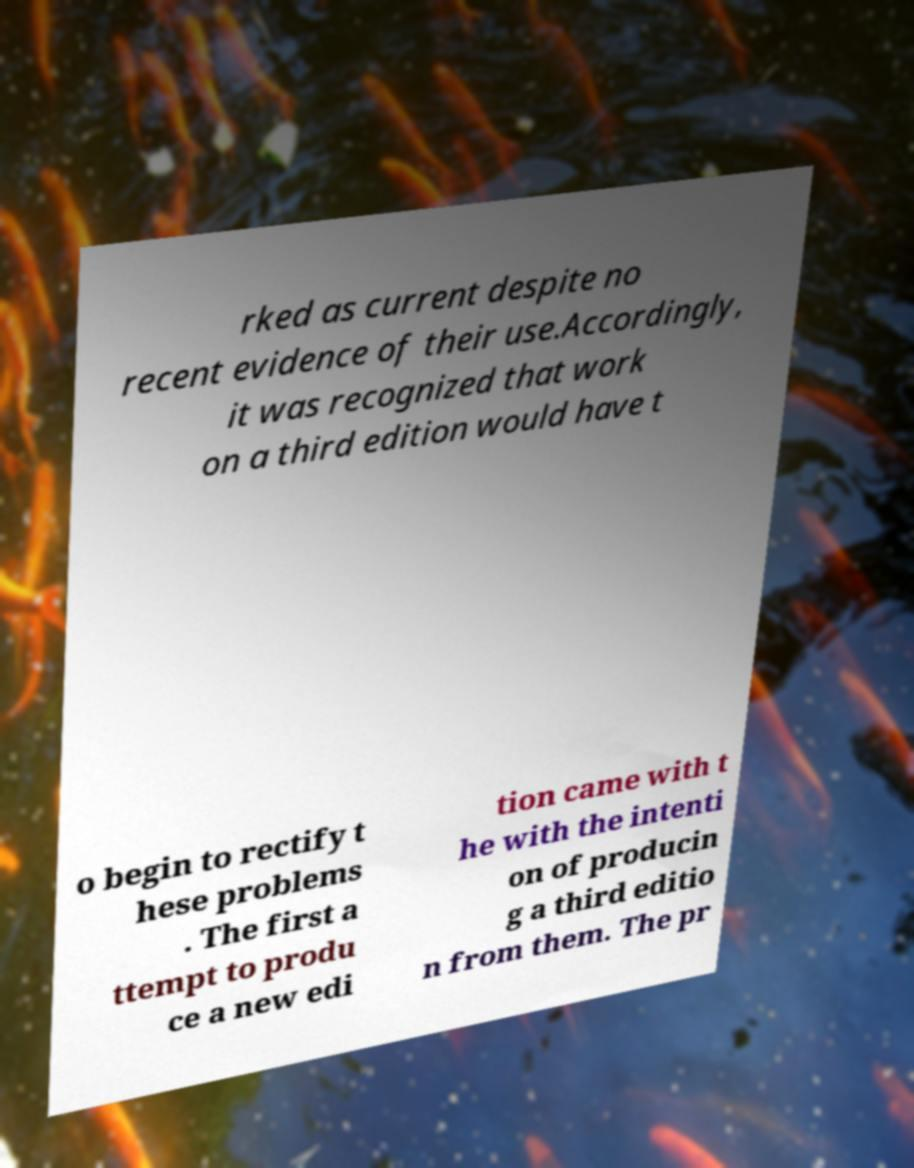Could you extract and type out the text from this image? rked as current despite no recent evidence of their use.Accordingly, it was recognized that work on a third edition would have t o begin to rectify t hese problems . The first a ttempt to produ ce a new edi tion came with t he with the intenti on of producin g a third editio n from them. The pr 